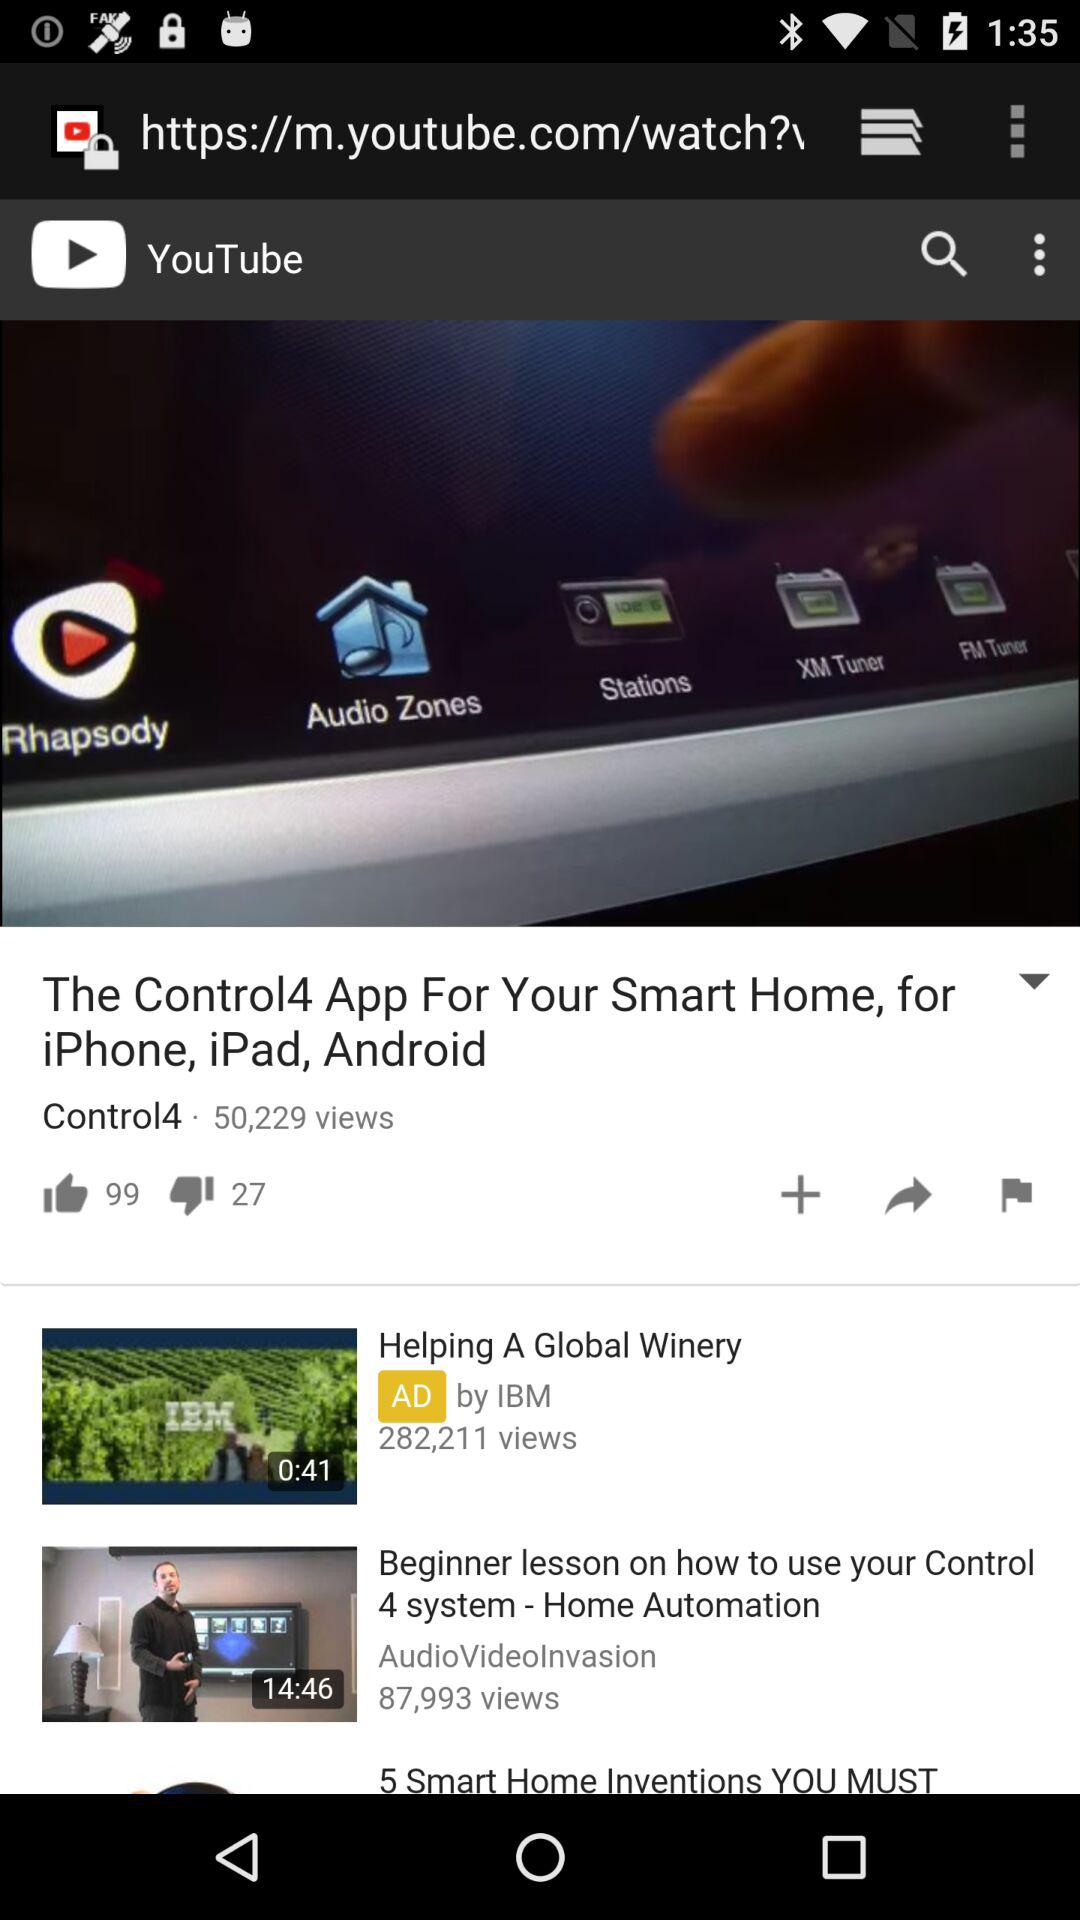How many views are there of "how to use your Control 4 system"? There are 87,993 views of "how to use your Control 4 system". 